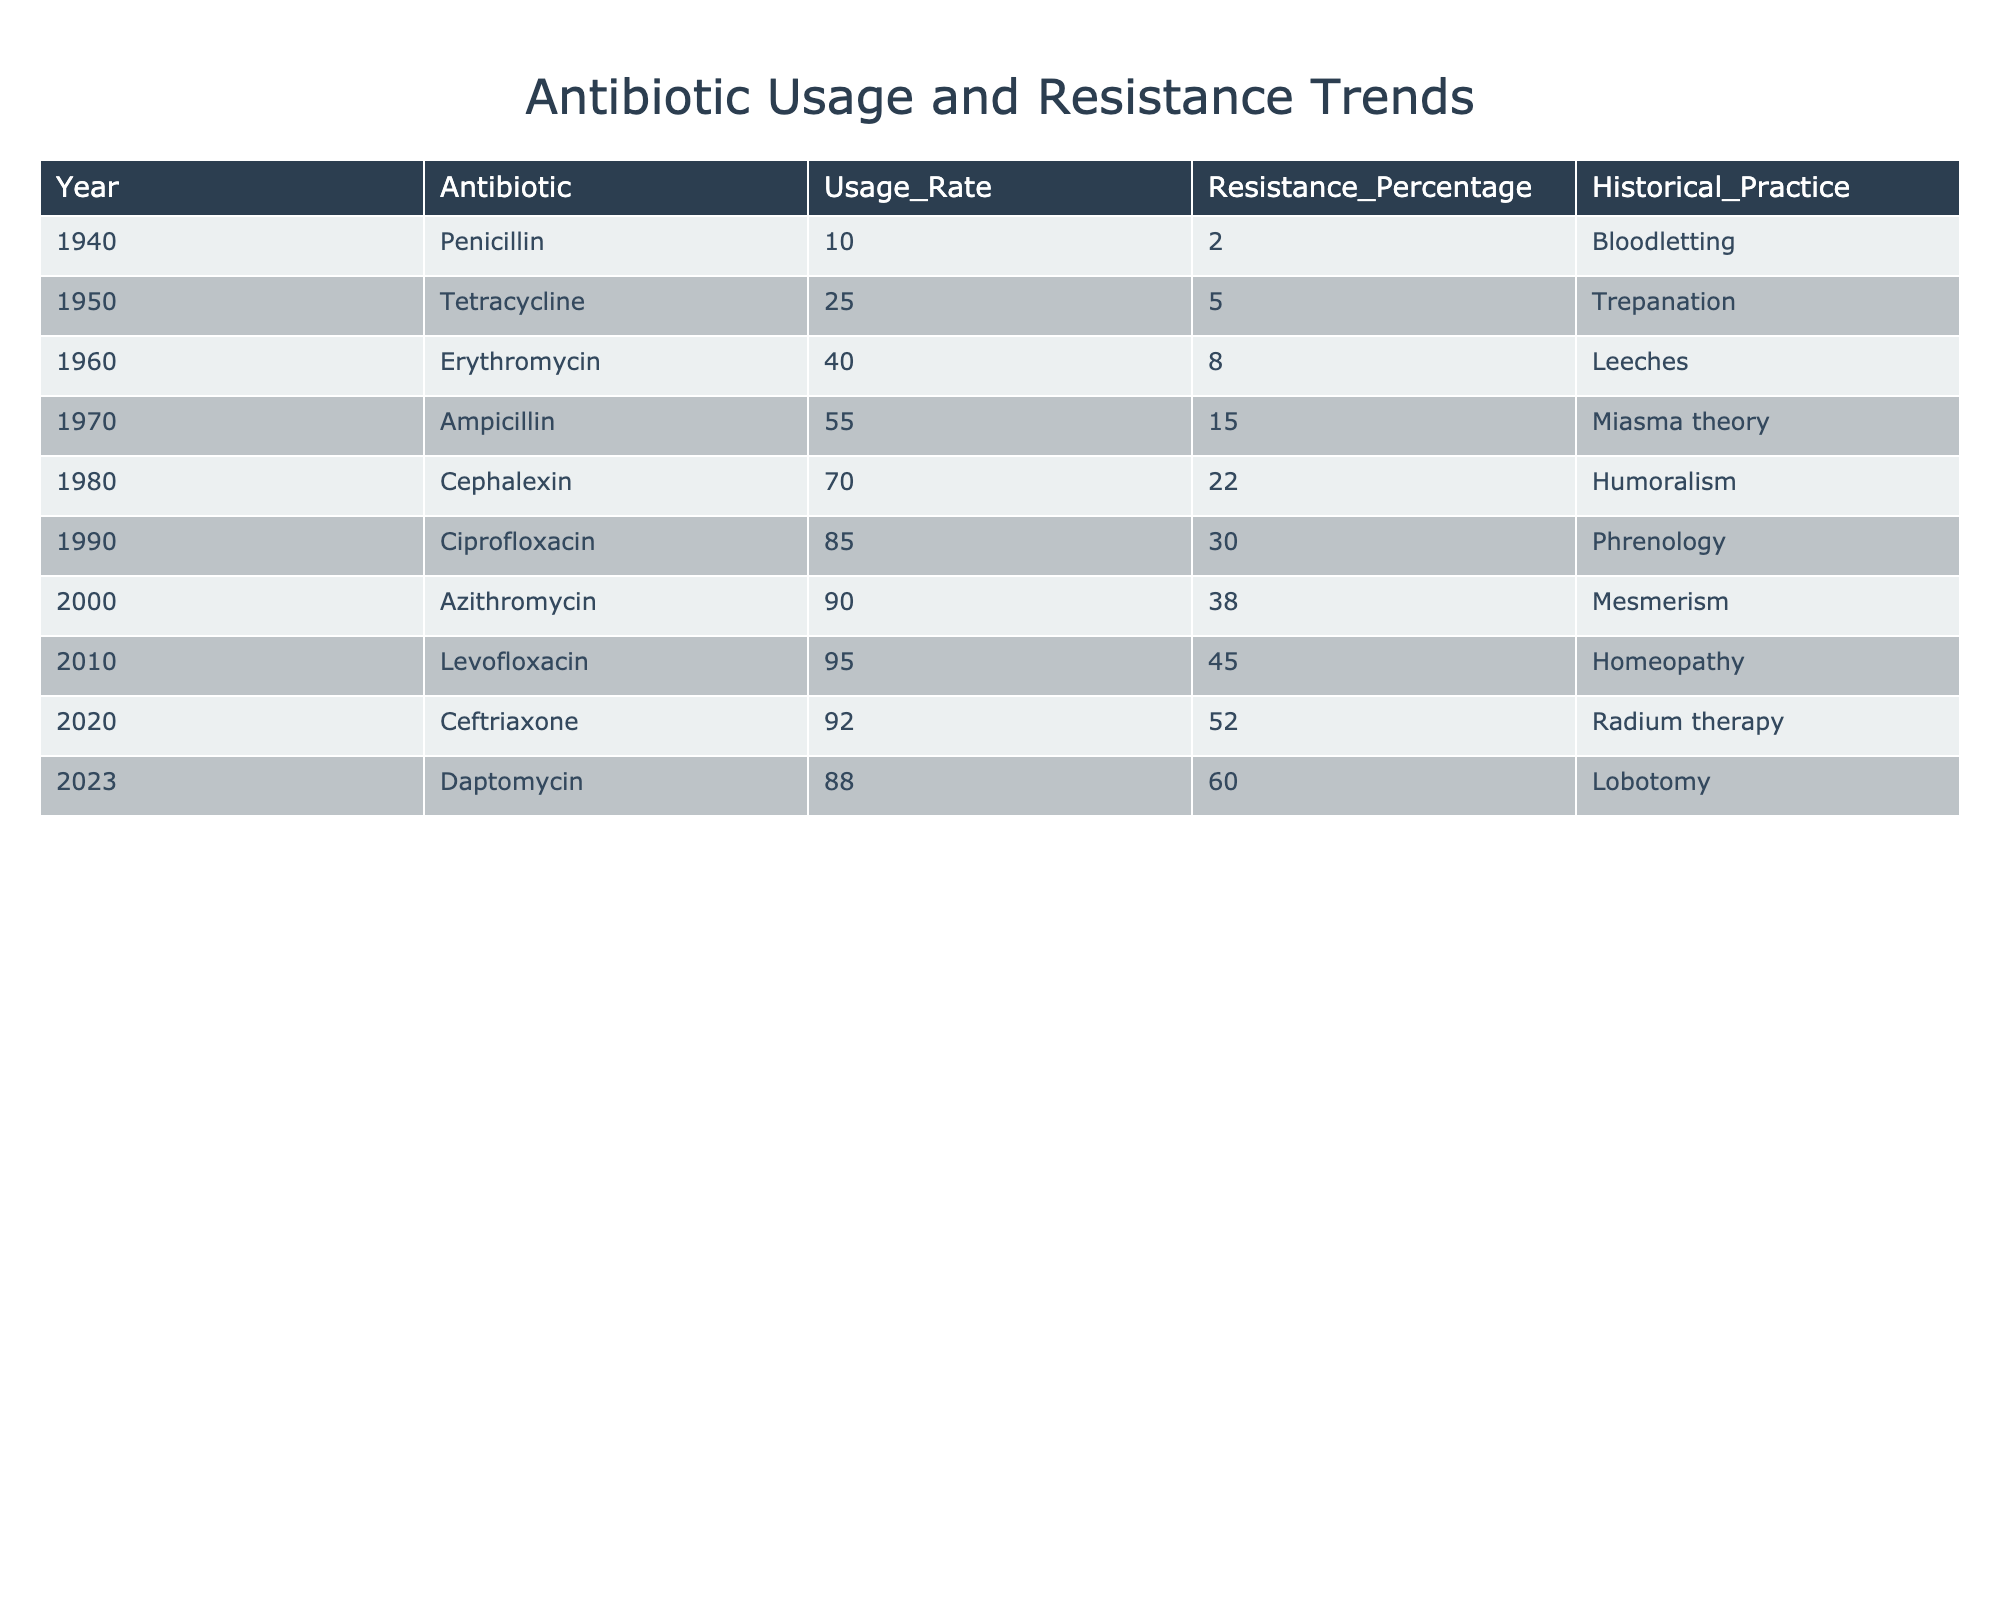What year had the highest antibiotic usage rate? The table indicates the usage rates for each year listed. By examining the "Usage_Rate" column, the highest value is 95 for the year 2010 corresponding to Levofloxacin.
Answer: 2010 What was the resistance percentage of Tetracycline in 1950? The table shows that the resistance percentage for Tetracycline in 1950 is 5% as stated in the "Resistance_Percentage" column.
Answer: 5% Which antibiotic had a usage rate less than 70? The antibiotics listed with a usage rate less than 70 are Penicillin (10), Tetracycline (25), Erythromycin (40), and Ampicillin (55). By focusing on the "Usage_Rate" column, these can be identified.
Answer: Penicillin, Tetracycline, Erythromycin, Ampicillin Calculate the average resistance percentage from 2000 to 2023. From the years 2000 to 2023, the resistance percentages are 38 (2000), 45 (2010), 52 (2020), and 60 (2023). The sum is 38 + 45 + 52 + 60 = 195, and there are 4 data points, so the average is 195/4 = 48.75.
Answer: 48.75 Was the resistance percentage ever below 10%? Looking at the "Resistance_Percentage" column, the data points for the years show percentages starting from 2% (Penicillin, 1940), confirming that there were instances when the resistance percentage was below 10%.
Answer: Yes What trend can be observed in antibiotic usage from 1940 to 2023? By analyzing the "Usage_Rate" column, we can see a consistent increase in antibiotic usage from 10% in 1940 to 88% in 2023, indicating a steady upward trend over the decades.
Answer: An increasing trend Which historical practice corresponds to the year with the highest resistance percentage? In 2023, the resistance percentage is 60%. Referring to the "Historical_Practice" column for that year, it shows the historical practice was Lobotomy associated with this high resistance percentage.
Answer: Lobotomy What is the difference between the highest and lowest recorded usage rates? The highest usage rate is 95 (2010, Levofloxacin) and the lowest is 10 (1940, Penicillin). The difference is calculated as 95 - 10 = 85.
Answer: 85 In which decade did the resistance percentage first exceed 30%? The table shows that the resistance percentage first exceeds 30% in 1990, when it reached 30%. Since the data indicates an increase from that point, it indicates that this was in the 1990s.
Answer: 1990s If we add the usage rates of all antibiotics from 1960 to 2020, what is the total? Looking at the "Usage_Rate" for Erythromycin (40), Ampicillin (55), Cephalexin (70), Ciprofloxacin (85), Azithromycin (90), and Ceftriaxone (92), we sum these values: 40 + 55 + 70 + 85 + 90 + 92 = 432.
Answer: 432 